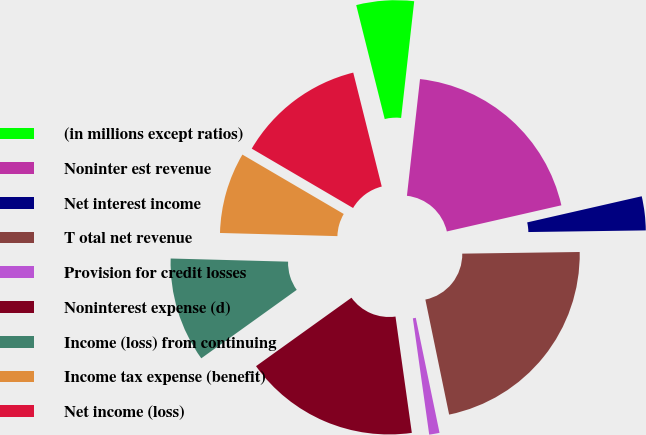Convert chart to OTSL. <chart><loc_0><loc_0><loc_500><loc_500><pie_chart><fcel>(in millions except ratios)<fcel>Noninter est revenue<fcel>Net interest income<fcel>T otal net revenue<fcel>Provision for credit losses<fcel>Noninterest expense (d)<fcel>Income (loss) from continuing<fcel>Income tax expense (benefit)<fcel>Net income (loss)<nl><fcel>5.68%<fcel>19.65%<fcel>3.35%<fcel>21.98%<fcel>1.02%<fcel>17.32%<fcel>10.33%<fcel>8.01%<fcel>12.66%<nl></chart> 